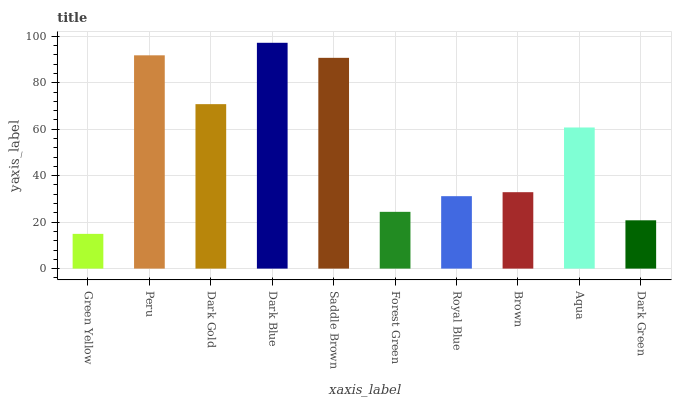Is Green Yellow the minimum?
Answer yes or no. Yes. Is Dark Blue the maximum?
Answer yes or no. Yes. Is Peru the minimum?
Answer yes or no. No. Is Peru the maximum?
Answer yes or no. No. Is Peru greater than Green Yellow?
Answer yes or no. Yes. Is Green Yellow less than Peru?
Answer yes or no. Yes. Is Green Yellow greater than Peru?
Answer yes or no. No. Is Peru less than Green Yellow?
Answer yes or no. No. Is Aqua the high median?
Answer yes or no. Yes. Is Brown the low median?
Answer yes or no. Yes. Is Royal Blue the high median?
Answer yes or no. No. Is Peru the low median?
Answer yes or no. No. 